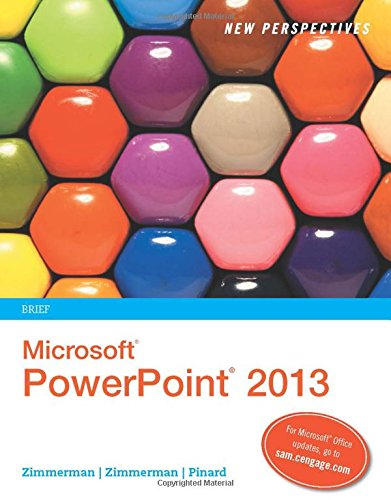What is the title of this book? The title of the book is 'New Perspectives on Microsoft PowerPoint 2013, Brief', part of the renowned New Perspectives Series. 